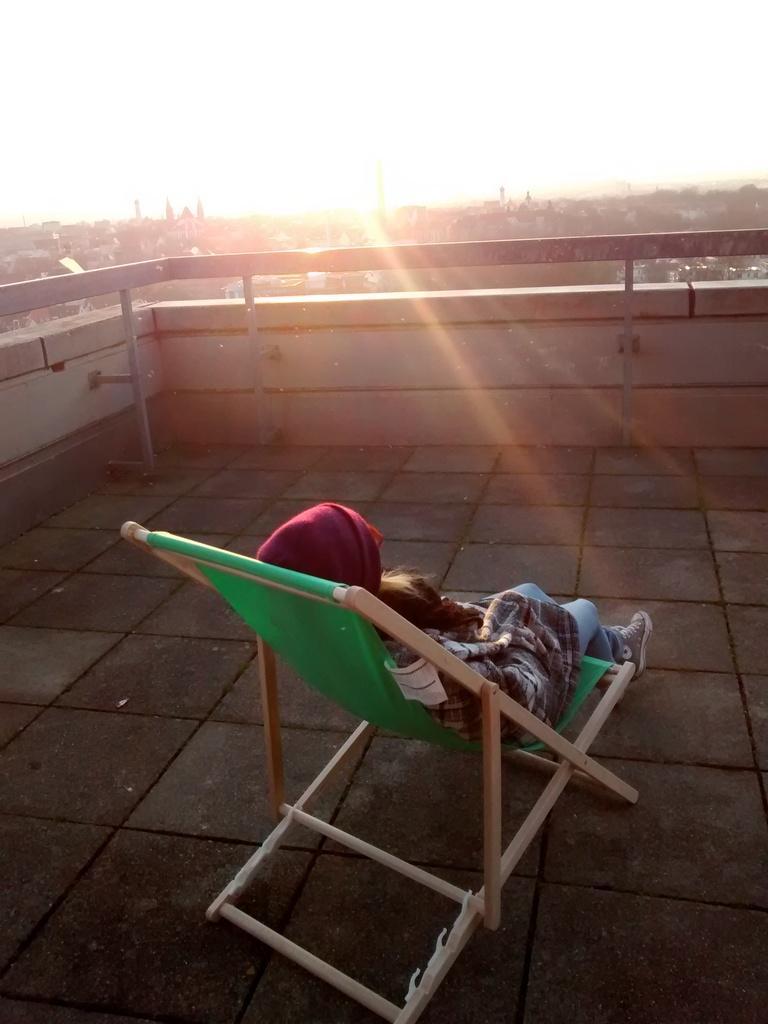Could you give a brief overview of what you see in this image? she is sitting on a chair. She is wearing a shoes. We can see in the background sky ,tree and wall. 